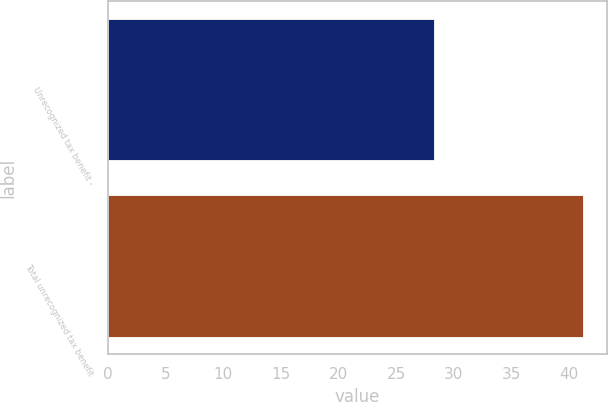Convert chart to OTSL. <chart><loc_0><loc_0><loc_500><loc_500><bar_chart><fcel>Unrecognized tax benefit -<fcel>Total unrecognized tax benefit<nl><fcel>28.3<fcel>41.2<nl></chart> 